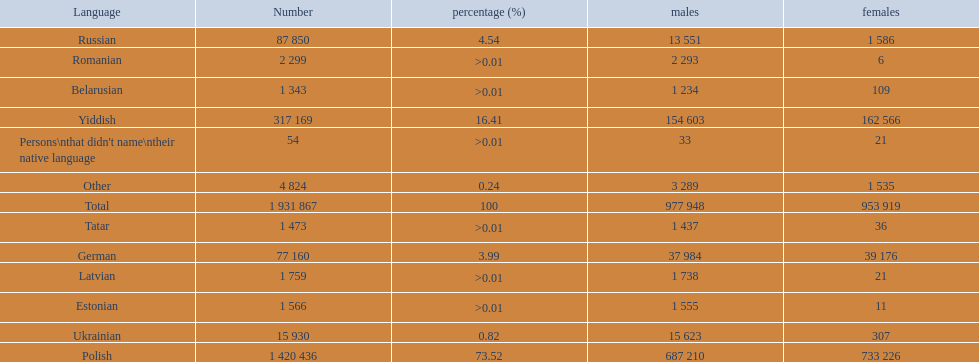Which languages are spoken by more than 50,000 people? Polish, Yiddish, Russian, German. Of these languages, which ones are spoken by less than 15% of the population? Russian, German. Of the remaining two, which one is spoken by 37,984 males? German. 